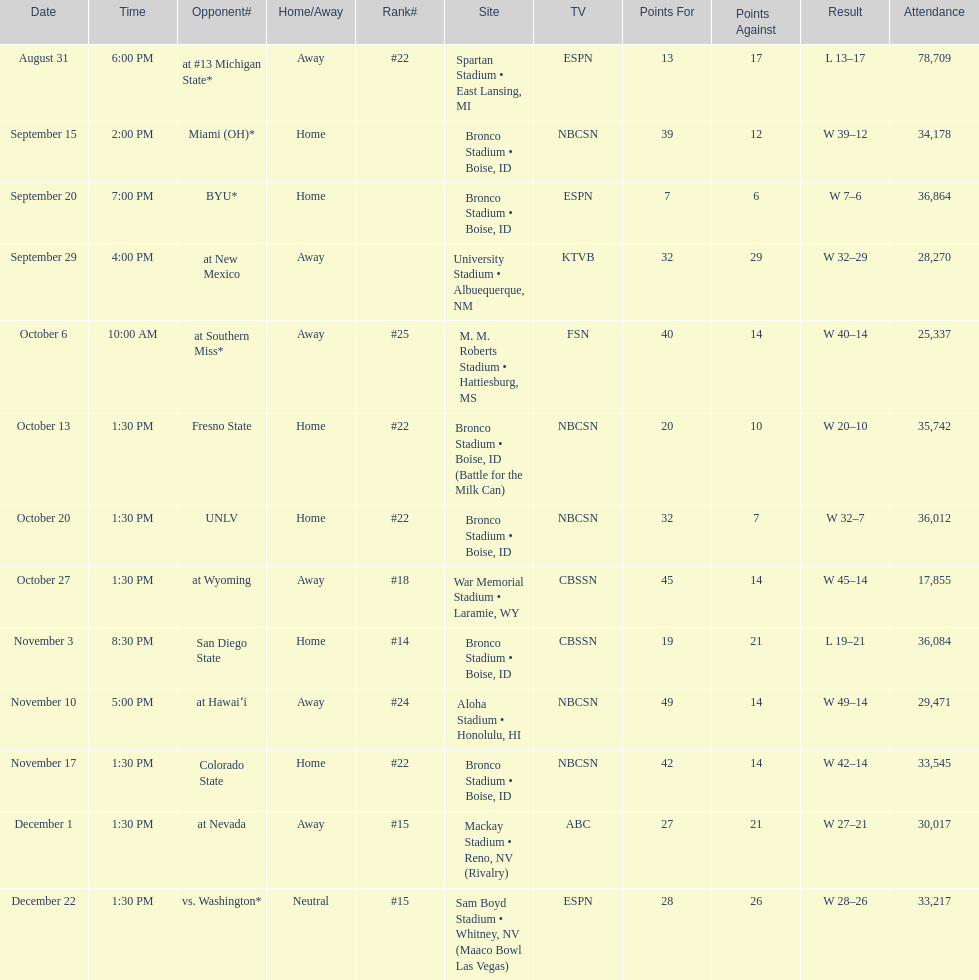Add up the total number of points scored in the last wins for boise state. 146. 